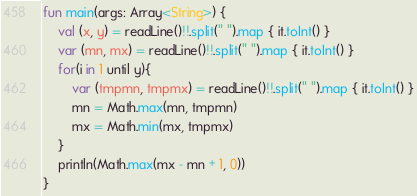<code> <loc_0><loc_0><loc_500><loc_500><_Kotlin_>fun main(args: Array<String>) {
    val (x, y) = readLine()!!.split(" ").map { it.toInt() }
    var (mn, mx) = readLine()!!.split(" ").map { it.toInt() }
    for(i in 1 until y){
        var (tmpmn, tmpmx) = readLine()!!.split(" ").map { it.toInt() }
        mn = Math.max(mn, tmpmn)
        mx = Math.min(mx, tmpmx)
    }
    println(Math.max(mx - mn + 1, 0))
}</code> 